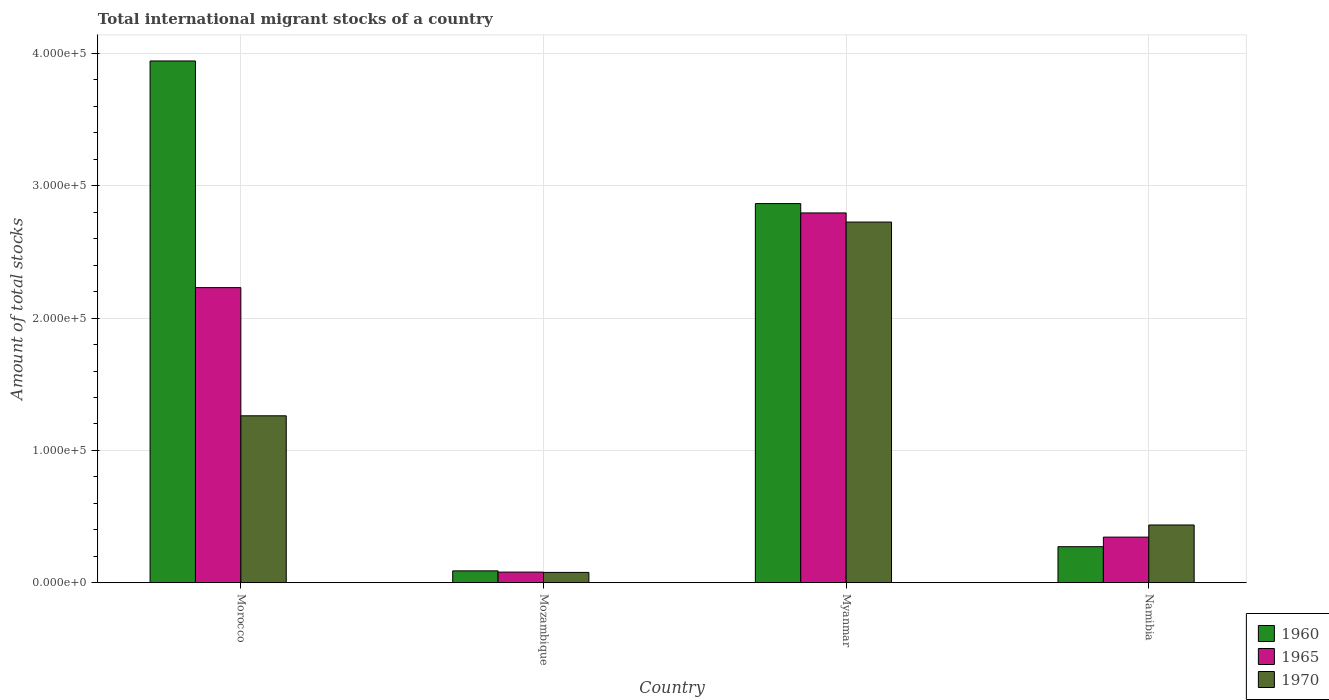How many different coloured bars are there?
Provide a short and direct response. 3. How many groups of bars are there?
Offer a very short reply. 4. Are the number of bars per tick equal to the number of legend labels?
Your answer should be very brief. Yes. Are the number of bars on each tick of the X-axis equal?
Keep it short and to the point. Yes. What is the label of the 2nd group of bars from the left?
Your answer should be compact. Mozambique. In how many cases, is the number of bars for a given country not equal to the number of legend labels?
Provide a succinct answer. 0. What is the amount of total stocks in in 1965 in Mozambique?
Your response must be concise. 8022. Across all countries, what is the maximum amount of total stocks in in 1970?
Give a very brief answer. 2.73e+05. Across all countries, what is the minimum amount of total stocks in in 1970?
Your answer should be compact. 7791. In which country was the amount of total stocks in in 1970 maximum?
Your answer should be very brief. Myanmar. In which country was the amount of total stocks in in 1960 minimum?
Give a very brief answer. Mozambique. What is the total amount of total stocks in in 1960 in the graph?
Offer a very short reply. 7.17e+05. What is the difference between the amount of total stocks in in 1965 in Mozambique and that in Myanmar?
Offer a very short reply. -2.71e+05. What is the difference between the amount of total stocks in in 1965 in Mozambique and the amount of total stocks in in 1960 in Namibia?
Provide a succinct answer. -1.92e+04. What is the average amount of total stocks in in 1960 per country?
Provide a succinct answer. 1.79e+05. What is the difference between the amount of total stocks in of/in 1970 and amount of total stocks in of/in 1965 in Namibia?
Ensure brevity in your answer.  9168. In how many countries, is the amount of total stocks in in 1965 greater than 100000?
Make the answer very short. 2. What is the ratio of the amount of total stocks in in 1960 in Myanmar to that in Namibia?
Keep it short and to the point. 10.53. What is the difference between the highest and the second highest amount of total stocks in in 1965?
Make the answer very short. -1.89e+05. What is the difference between the highest and the lowest amount of total stocks in in 1960?
Make the answer very short. 3.85e+05. In how many countries, is the amount of total stocks in in 1960 greater than the average amount of total stocks in in 1960 taken over all countries?
Your answer should be compact. 2. What does the 2nd bar from the left in Myanmar represents?
Ensure brevity in your answer.  1965. Is it the case that in every country, the sum of the amount of total stocks in in 1965 and amount of total stocks in in 1960 is greater than the amount of total stocks in in 1970?
Ensure brevity in your answer.  Yes. How many bars are there?
Your response must be concise. 12. Are all the bars in the graph horizontal?
Offer a terse response. No. What is the difference between two consecutive major ticks on the Y-axis?
Provide a succinct answer. 1.00e+05. Does the graph contain grids?
Make the answer very short. Yes. What is the title of the graph?
Your response must be concise. Total international migrant stocks of a country. What is the label or title of the Y-axis?
Your answer should be very brief. Amount of total stocks. What is the Amount of total stocks of 1960 in Morocco?
Provide a short and direct response. 3.94e+05. What is the Amount of total stocks in 1965 in Morocco?
Keep it short and to the point. 2.23e+05. What is the Amount of total stocks of 1970 in Morocco?
Make the answer very short. 1.26e+05. What is the Amount of total stocks of 1960 in Mozambique?
Offer a very short reply. 8949. What is the Amount of total stocks in 1965 in Mozambique?
Ensure brevity in your answer.  8022. What is the Amount of total stocks of 1970 in Mozambique?
Your answer should be compact. 7791. What is the Amount of total stocks of 1960 in Myanmar?
Offer a terse response. 2.87e+05. What is the Amount of total stocks of 1965 in Myanmar?
Provide a short and direct response. 2.79e+05. What is the Amount of total stocks of 1970 in Myanmar?
Offer a terse response. 2.73e+05. What is the Amount of total stocks of 1960 in Namibia?
Make the answer very short. 2.72e+04. What is the Amount of total stocks in 1965 in Namibia?
Offer a terse response. 3.45e+04. What is the Amount of total stocks in 1970 in Namibia?
Offer a terse response. 4.36e+04. Across all countries, what is the maximum Amount of total stocks in 1960?
Ensure brevity in your answer.  3.94e+05. Across all countries, what is the maximum Amount of total stocks in 1965?
Keep it short and to the point. 2.79e+05. Across all countries, what is the maximum Amount of total stocks in 1970?
Provide a succinct answer. 2.73e+05. Across all countries, what is the minimum Amount of total stocks in 1960?
Your response must be concise. 8949. Across all countries, what is the minimum Amount of total stocks in 1965?
Make the answer very short. 8022. Across all countries, what is the minimum Amount of total stocks in 1970?
Keep it short and to the point. 7791. What is the total Amount of total stocks in 1960 in the graph?
Provide a succinct answer. 7.17e+05. What is the total Amount of total stocks in 1965 in the graph?
Offer a terse response. 5.45e+05. What is the total Amount of total stocks in 1970 in the graph?
Give a very brief answer. 4.50e+05. What is the difference between the Amount of total stocks in 1960 in Morocco and that in Mozambique?
Keep it short and to the point. 3.85e+05. What is the difference between the Amount of total stocks in 1965 in Morocco and that in Mozambique?
Offer a terse response. 2.15e+05. What is the difference between the Amount of total stocks of 1970 in Morocco and that in Mozambique?
Provide a short and direct response. 1.18e+05. What is the difference between the Amount of total stocks of 1960 in Morocco and that in Myanmar?
Your response must be concise. 1.08e+05. What is the difference between the Amount of total stocks of 1965 in Morocco and that in Myanmar?
Offer a terse response. -5.64e+04. What is the difference between the Amount of total stocks in 1970 in Morocco and that in Myanmar?
Provide a short and direct response. -1.46e+05. What is the difference between the Amount of total stocks of 1960 in Morocco and that in Namibia?
Provide a short and direct response. 3.67e+05. What is the difference between the Amount of total stocks of 1965 in Morocco and that in Namibia?
Provide a succinct answer. 1.89e+05. What is the difference between the Amount of total stocks of 1970 in Morocco and that in Namibia?
Give a very brief answer. 8.25e+04. What is the difference between the Amount of total stocks of 1960 in Mozambique and that in Myanmar?
Offer a terse response. -2.78e+05. What is the difference between the Amount of total stocks of 1965 in Mozambique and that in Myanmar?
Your response must be concise. -2.71e+05. What is the difference between the Amount of total stocks of 1970 in Mozambique and that in Myanmar?
Your response must be concise. -2.65e+05. What is the difference between the Amount of total stocks of 1960 in Mozambique and that in Namibia?
Keep it short and to the point. -1.83e+04. What is the difference between the Amount of total stocks in 1965 in Mozambique and that in Namibia?
Ensure brevity in your answer.  -2.64e+04. What is the difference between the Amount of total stocks in 1970 in Mozambique and that in Namibia?
Keep it short and to the point. -3.58e+04. What is the difference between the Amount of total stocks in 1960 in Myanmar and that in Namibia?
Keep it short and to the point. 2.59e+05. What is the difference between the Amount of total stocks of 1965 in Myanmar and that in Namibia?
Provide a short and direct response. 2.45e+05. What is the difference between the Amount of total stocks in 1970 in Myanmar and that in Namibia?
Provide a short and direct response. 2.29e+05. What is the difference between the Amount of total stocks of 1960 in Morocco and the Amount of total stocks of 1965 in Mozambique?
Make the answer very short. 3.86e+05. What is the difference between the Amount of total stocks of 1960 in Morocco and the Amount of total stocks of 1970 in Mozambique?
Keep it short and to the point. 3.87e+05. What is the difference between the Amount of total stocks of 1965 in Morocco and the Amount of total stocks of 1970 in Mozambique?
Your answer should be compact. 2.15e+05. What is the difference between the Amount of total stocks of 1960 in Morocco and the Amount of total stocks of 1965 in Myanmar?
Your response must be concise. 1.15e+05. What is the difference between the Amount of total stocks of 1960 in Morocco and the Amount of total stocks of 1970 in Myanmar?
Ensure brevity in your answer.  1.22e+05. What is the difference between the Amount of total stocks of 1965 in Morocco and the Amount of total stocks of 1970 in Myanmar?
Your answer should be very brief. -4.96e+04. What is the difference between the Amount of total stocks of 1960 in Morocco and the Amount of total stocks of 1965 in Namibia?
Your answer should be compact. 3.60e+05. What is the difference between the Amount of total stocks of 1960 in Morocco and the Amount of total stocks of 1970 in Namibia?
Your answer should be compact. 3.51e+05. What is the difference between the Amount of total stocks in 1965 in Morocco and the Amount of total stocks in 1970 in Namibia?
Your answer should be very brief. 1.79e+05. What is the difference between the Amount of total stocks of 1960 in Mozambique and the Amount of total stocks of 1965 in Myanmar?
Make the answer very short. -2.71e+05. What is the difference between the Amount of total stocks in 1960 in Mozambique and the Amount of total stocks in 1970 in Myanmar?
Offer a very short reply. -2.64e+05. What is the difference between the Amount of total stocks in 1965 in Mozambique and the Amount of total stocks in 1970 in Myanmar?
Your answer should be very brief. -2.65e+05. What is the difference between the Amount of total stocks in 1960 in Mozambique and the Amount of total stocks in 1965 in Namibia?
Provide a short and direct response. -2.55e+04. What is the difference between the Amount of total stocks of 1960 in Mozambique and the Amount of total stocks of 1970 in Namibia?
Ensure brevity in your answer.  -3.47e+04. What is the difference between the Amount of total stocks of 1965 in Mozambique and the Amount of total stocks of 1970 in Namibia?
Keep it short and to the point. -3.56e+04. What is the difference between the Amount of total stocks of 1960 in Myanmar and the Amount of total stocks of 1965 in Namibia?
Give a very brief answer. 2.52e+05. What is the difference between the Amount of total stocks of 1960 in Myanmar and the Amount of total stocks of 1970 in Namibia?
Provide a succinct answer. 2.43e+05. What is the difference between the Amount of total stocks of 1965 in Myanmar and the Amount of total stocks of 1970 in Namibia?
Offer a terse response. 2.36e+05. What is the average Amount of total stocks in 1960 per country?
Ensure brevity in your answer.  1.79e+05. What is the average Amount of total stocks in 1965 per country?
Give a very brief answer. 1.36e+05. What is the average Amount of total stocks of 1970 per country?
Your answer should be very brief. 1.13e+05. What is the difference between the Amount of total stocks of 1960 and Amount of total stocks of 1965 in Morocco?
Make the answer very short. 1.71e+05. What is the difference between the Amount of total stocks in 1960 and Amount of total stocks in 1970 in Morocco?
Keep it short and to the point. 2.68e+05. What is the difference between the Amount of total stocks of 1965 and Amount of total stocks of 1970 in Morocco?
Your answer should be very brief. 9.69e+04. What is the difference between the Amount of total stocks in 1960 and Amount of total stocks in 1965 in Mozambique?
Keep it short and to the point. 927. What is the difference between the Amount of total stocks of 1960 and Amount of total stocks of 1970 in Mozambique?
Ensure brevity in your answer.  1158. What is the difference between the Amount of total stocks in 1965 and Amount of total stocks in 1970 in Mozambique?
Offer a terse response. 231. What is the difference between the Amount of total stocks of 1960 and Amount of total stocks of 1965 in Myanmar?
Your answer should be compact. 7075. What is the difference between the Amount of total stocks of 1960 and Amount of total stocks of 1970 in Myanmar?
Offer a very short reply. 1.40e+04. What is the difference between the Amount of total stocks in 1965 and Amount of total stocks in 1970 in Myanmar?
Keep it short and to the point. 6900. What is the difference between the Amount of total stocks in 1960 and Amount of total stocks in 1965 in Namibia?
Offer a very short reply. -7242. What is the difference between the Amount of total stocks in 1960 and Amount of total stocks in 1970 in Namibia?
Provide a succinct answer. -1.64e+04. What is the difference between the Amount of total stocks in 1965 and Amount of total stocks in 1970 in Namibia?
Keep it short and to the point. -9168. What is the ratio of the Amount of total stocks of 1960 in Morocco to that in Mozambique?
Offer a very short reply. 44.07. What is the ratio of the Amount of total stocks of 1965 in Morocco to that in Mozambique?
Offer a very short reply. 27.8. What is the ratio of the Amount of total stocks of 1970 in Morocco to that in Mozambique?
Provide a short and direct response. 16.19. What is the ratio of the Amount of total stocks in 1960 in Morocco to that in Myanmar?
Provide a short and direct response. 1.38. What is the ratio of the Amount of total stocks in 1965 in Morocco to that in Myanmar?
Your answer should be compact. 0.8. What is the ratio of the Amount of total stocks of 1970 in Morocco to that in Myanmar?
Your answer should be very brief. 0.46. What is the ratio of the Amount of total stocks of 1960 in Morocco to that in Namibia?
Offer a terse response. 14.49. What is the ratio of the Amount of total stocks in 1965 in Morocco to that in Namibia?
Make the answer very short. 6.47. What is the ratio of the Amount of total stocks of 1970 in Morocco to that in Namibia?
Provide a short and direct response. 2.89. What is the ratio of the Amount of total stocks of 1960 in Mozambique to that in Myanmar?
Keep it short and to the point. 0.03. What is the ratio of the Amount of total stocks in 1965 in Mozambique to that in Myanmar?
Your response must be concise. 0.03. What is the ratio of the Amount of total stocks of 1970 in Mozambique to that in Myanmar?
Give a very brief answer. 0.03. What is the ratio of the Amount of total stocks in 1960 in Mozambique to that in Namibia?
Ensure brevity in your answer.  0.33. What is the ratio of the Amount of total stocks in 1965 in Mozambique to that in Namibia?
Keep it short and to the point. 0.23. What is the ratio of the Amount of total stocks in 1970 in Mozambique to that in Namibia?
Your answer should be very brief. 0.18. What is the ratio of the Amount of total stocks of 1960 in Myanmar to that in Namibia?
Offer a terse response. 10.53. What is the ratio of the Amount of total stocks in 1965 in Myanmar to that in Namibia?
Offer a terse response. 8.11. What is the ratio of the Amount of total stocks in 1970 in Myanmar to that in Namibia?
Keep it short and to the point. 6.25. What is the difference between the highest and the second highest Amount of total stocks in 1960?
Ensure brevity in your answer.  1.08e+05. What is the difference between the highest and the second highest Amount of total stocks in 1965?
Provide a short and direct response. 5.64e+04. What is the difference between the highest and the second highest Amount of total stocks in 1970?
Make the answer very short. 1.46e+05. What is the difference between the highest and the lowest Amount of total stocks in 1960?
Your response must be concise. 3.85e+05. What is the difference between the highest and the lowest Amount of total stocks of 1965?
Make the answer very short. 2.71e+05. What is the difference between the highest and the lowest Amount of total stocks of 1970?
Provide a short and direct response. 2.65e+05. 